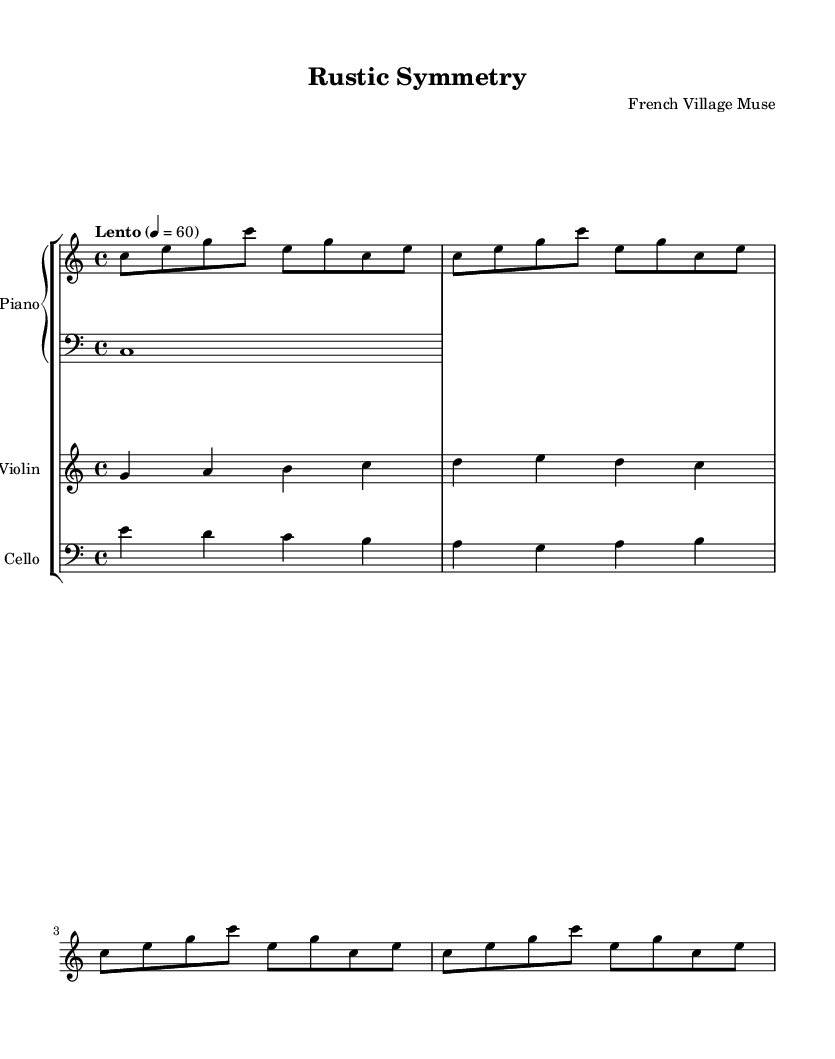What is the key signature of this music? The key signature is indicated at the beginning of the staff, showing no sharps or flats, which corresponds to C major.
Answer: C major What is the time signature of this piece? The time signature, shown as a fraction at the beginning of the staff, is 4 over 4, meaning there are four beats per measure.
Answer: 4/4 What is the tempo marking for this composition? The tempo marking, located above the staff, uses the term "Lento," indicating a slow tempo, and specifies a metronome marking of 60 beats per minute.
Answer: Lento 4 = 60 How many measures are in the piano's right-hand part? By counting the groupings of notes in the right-hand part specifically, there are four measures containing repeated patterns indicating a total of four measures of music.
Answer: 4 What instruments are included in this composition? The instruments are indicated on their respective staves: the Piano, Violin, and Cello are all explicitly named in the score.
Answer: Piano, Violin, Cello Which musical element is primarily featured to evoke a sense of "minimalism"? The right-hand piano part repeats a simple pattern with a limited note range, creating a minimalist texture characteristic of the style.
Answer: Repetition What is the highest note that appears in the Violin part? By inspecting the violin section, the highest note is a C, found as the fourth note in the ascending sequence of the measures.
Answer: C 